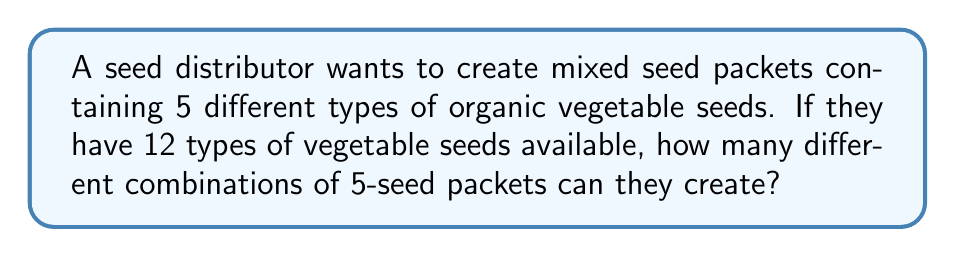Can you solve this math problem? To solve this problem, we need to use the combination formula. We are selecting 5 seeds out of 12 available types, where the order doesn't matter (as it's a mixed packet).

1. The formula for combinations is:

   $$C(n,r) = \frac{n!}{r!(n-r)!}$$

   Where $n$ is the total number of items to choose from, and $r$ is the number of items being chosen.

2. In this case, $n = 12$ (total seed types) and $r = 5$ (seeds in each packet).

3. Let's substitute these values into the formula:

   $$C(12,5) = \frac{12!}{5!(12-5)!} = \frac{12!}{5!(7)!}$$

4. Expand this:
   
   $$\frac{12 \times 11 \times 10 \times 9 \times 8 \times 7!}{(5 \times 4 \times 3 \times 2 \times 1) \times 7!}$$

5. The $7!$ cancels out in the numerator and denominator:

   $$\frac{12 \times 11 \times 10 \times 9 \times 8}{5 \times 4 \times 3 \times 2 \times 1}$$

6. Multiply the numerator and denominator:

   $$\frac{95,040}{120} = 792$$

Therefore, the seed distributor can create 792 different combinations of 5-seed packets from the 12 available vegetable seed types.
Answer: 792 